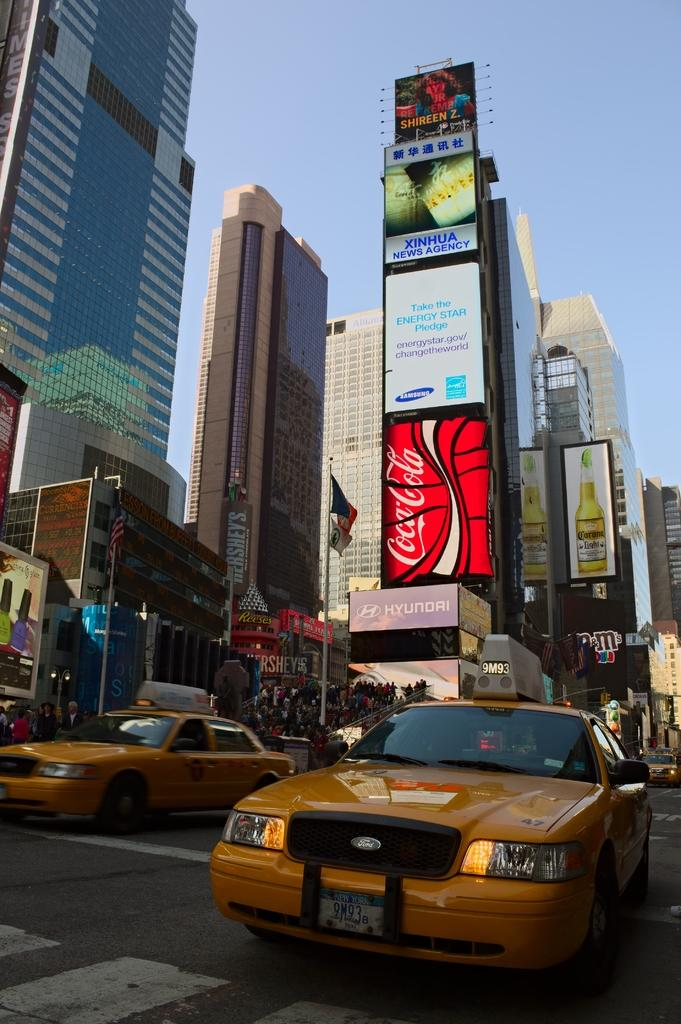<image>
Write a terse but informative summary of the picture. A yellow taxi with 9M93 on the sign above it. 